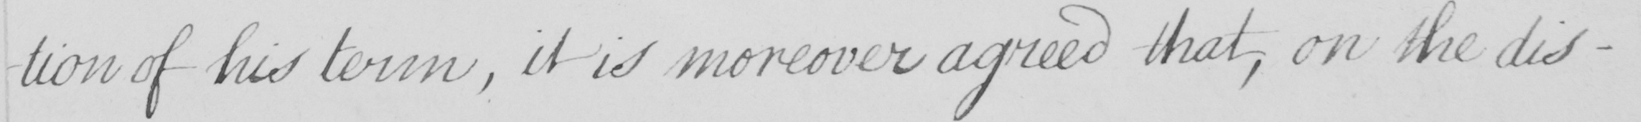What text is written in this handwritten line? -tion of his term , it is moreover agreed that , on the dis- 